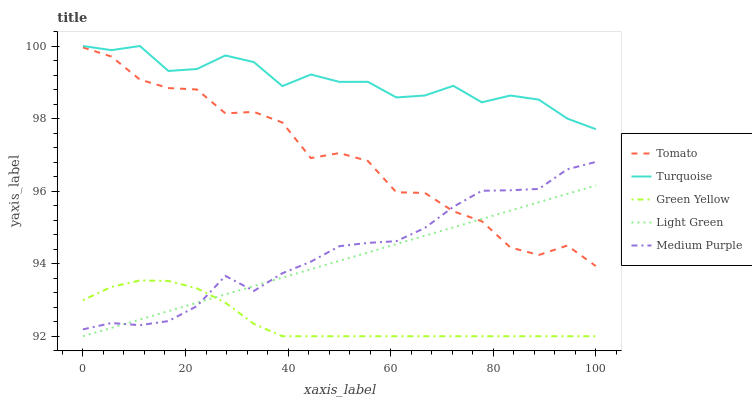Does Green Yellow have the minimum area under the curve?
Answer yes or no. Yes. Does Turquoise have the maximum area under the curve?
Answer yes or no. Yes. Does Medium Purple have the minimum area under the curve?
Answer yes or no. No. Does Medium Purple have the maximum area under the curve?
Answer yes or no. No. Is Light Green the smoothest?
Answer yes or no. Yes. Is Tomato the roughest?
Answer yes or no. Yes. Is Medium Purple the smoothest?
Answer yes or no. No. Is Medium Purple the roughest?
Answer yes or no. No. Does Green Yellow have the lowest value?
Answer yes or no. Yes. Does Medium Purple have the lowest value?
Answer yes or no. No. Does Turquoise have the highest value?
Answer yes or no. Yes. Does Medium Purple have the highest value?
Answer yes or no. No. Is Green Yellow less than Turquoise?
Answer yes or no. Yes. Is Tomato greater than Green Yellow?
Answer yes or no. Yes. Does Tomato intersect Medium Purple?
Answer yes or no. Yes. Is Tomato less than Medium Purple?
Answer yes or no. No. Is Tomato greater than Medium Purple?
Answer yes or no. No. Does Green Yellow intersect Turquoise?
Answer yes or no. No. 